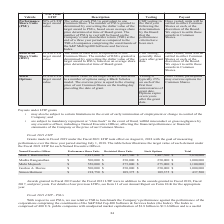According to Opentext Corporation's financial document, What does the table represent? illustrates the target value of each element under the Fiscal 2021 LTIP for each Named Executive Officer. The document states: "ear period starting July 1, 2018. The table below illustrates the target value of each element under the Fiscal 2021 LTIP for each Named Executive Off..." Also, Who are the Named Executive Officers? The document contains multiple relevant values: Mark J. Barrenechea, Madhu Ranganathan, Muhi Majzoub, Gordon A. Davies, Simon Harrison. From the document: "Gordon A. Davies $ 500,000 $ 250,000 $ 250,000 $ 1,000,000 Simon Harrison $ 218,750 $ 109,375 $ 109,375 $ 437,500 Units Restricted Share Units Stock O..." Also, What is the total target value for Mark J. Barrenechea? According to the financial document, 5,630,000. The relevant text states: "Barrenechea $ 2,815,000 $ 1,407,500 $ 1,407,500 $ 5,630,000 Madhu Ranganathan $ 500,000 $ 250,000 $ 250,000 $ 1,000,000 Muhi Majzoub $ 550,000 $ 275,000 $ 275,..." Also, can you calculate: What is the average total target value for all Named Executive Officers? To answer this question, I need to perform calculations using the financial data. The calculation is: (5,630,000+1,000,000+1,100,000+1,000,000+437,500)/5, which equals 1833500. This is based on the information: "Barrenechea $ 2,815,000 $ 1,407,500 $ 1,407,500 $ 5,630,000 Madhu Ranganathan $ 500,000 $ 250,000 $ 250,000 $ 1,000,000 Muhi Majzoub $ 550,000 $ 275,000 $ 275, ,000 Muhi Majzoub $ 550,000 $ 275,000 $ ..." The key data points involved are: 1,000,000, 1,100,000, 437,500. Also, can you calculate: What is Mark J. Barrenechea's Total target value expressed as percentage of total target values for all Named Executive Officer? To answer this question, I need to perform calculations using the financial data. The calculation is: 5,630,000/(5,630,000+1,000,000+1,100,000+1,000,000+437,500), which equals 61.41 (percentage). This is based on the information: "Barrenechea $ 2,815,000 $ 1,407,500 $ 1,407,500 $ 5,630,000 Madhu Ranganathan $ 500,000 $ 250,000 $ 250,000 $ 1,000,000 Muhi Majzoub $ 550,000 $ 275,000 $ 275, ,000 Muhi Majzoub $ 550,000 $ 275,000 $ ..." The key data points involved are: 1,000,000, 1,100,000, 437,500. Also, can you calculate: What is Simon Harrison's Total target value expressed as percentage of total target values for all Named Executive Officer? To answer this question, I need to perform calculations using the financial data. The calculation is: 437,500/(5,630,000+1,000,000+1,100,000+1,000,000+437,500), which equals 4.77 (percentage). This is based on the information: "00 Simon Harrison $ 218,750 $ 109,375 $ 109,375 $ 437,500 ,000 Muhi Majzoub $ 550,000 $ 275,000 $ 275,000 $ 1,100,000 Barrenechea $ 2,815,000 $ 1,407,500 $ 1,407,500 $ 5,630,000 Madhu Ranganathan $ 50..." The key data points involved are: 1,000,000, 1,100,000, 437,500. 